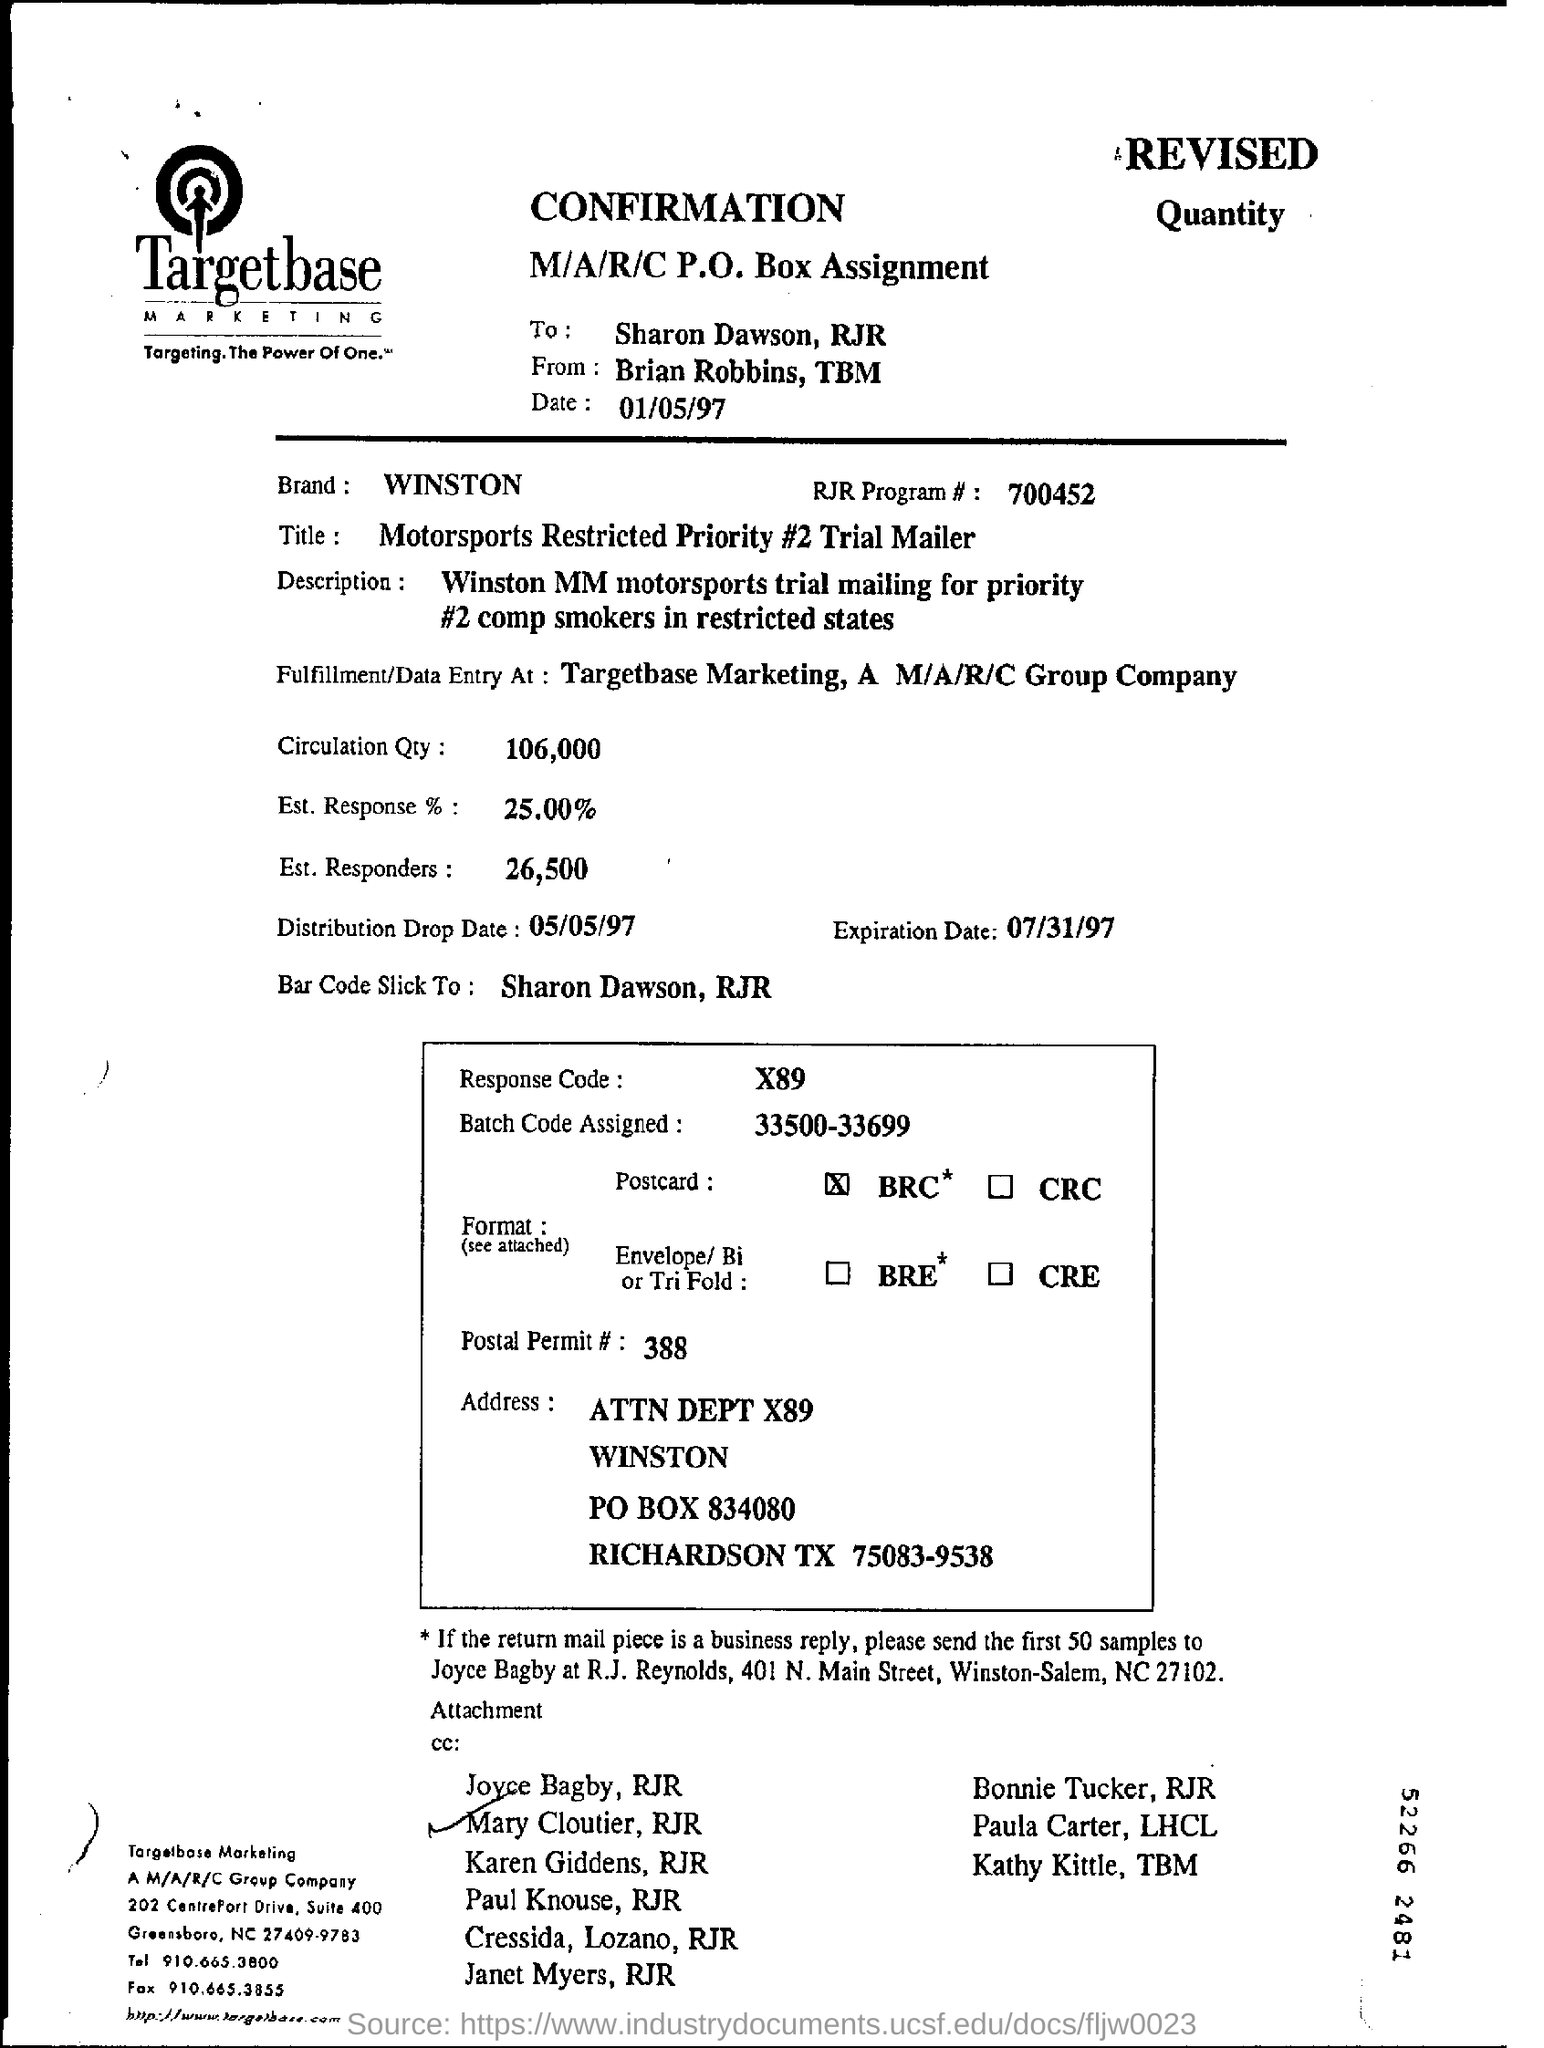Outline some significant characteristics in this image. The expiration date is 07/31/97. I have determined that the brand name is Winston. The name of the person listed at the bottom of the page is Mary Cloutier, RJR. 